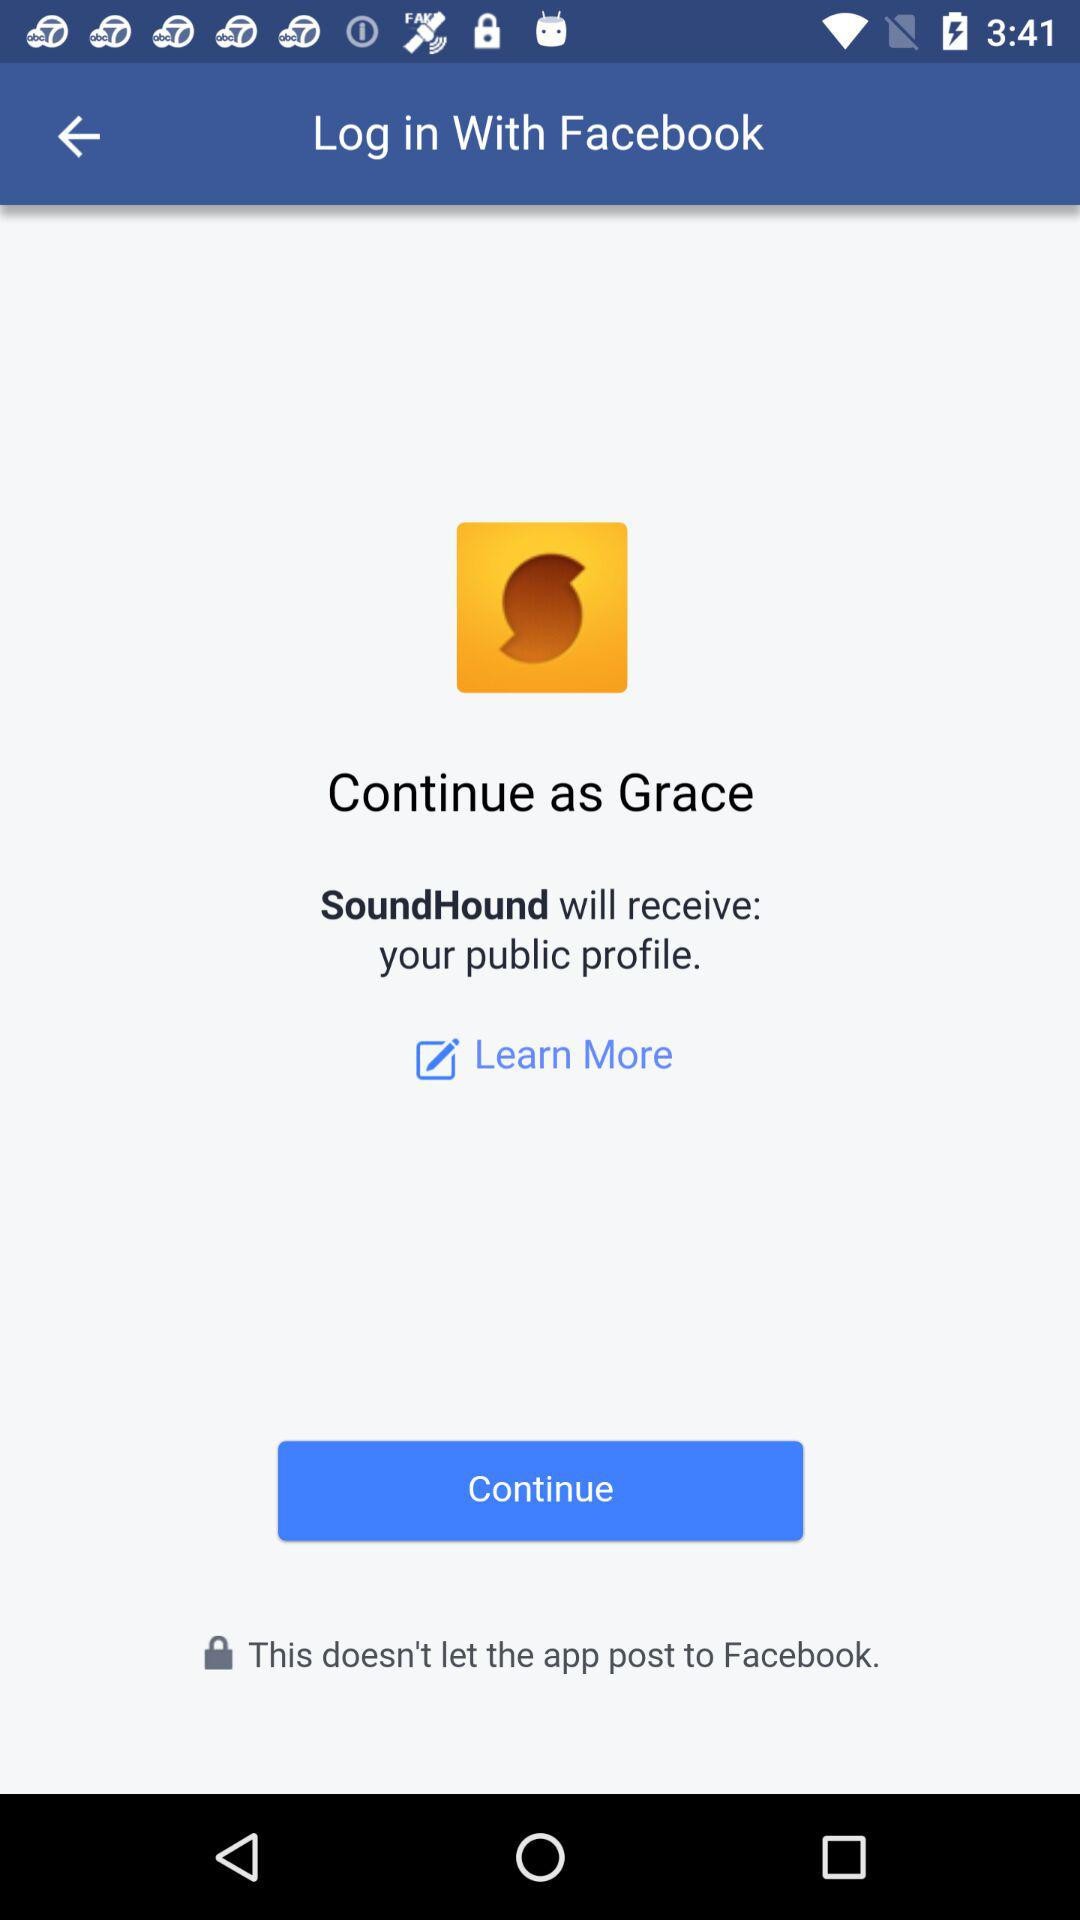Through what app can I log in? You can log in through "Facebook". 